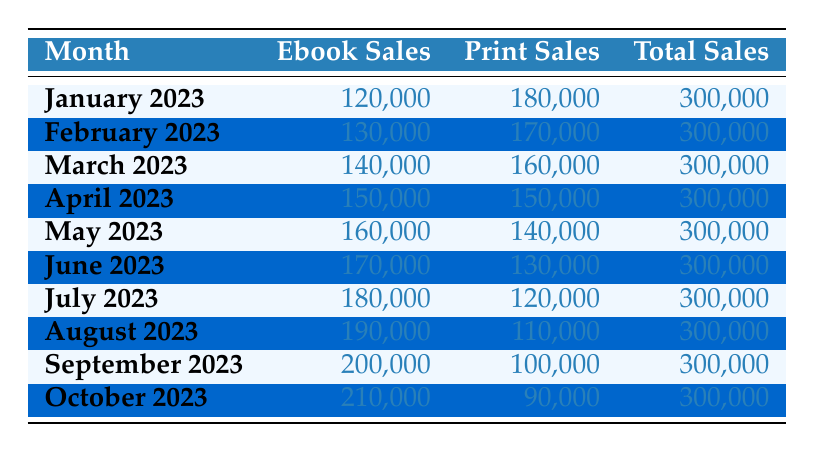What were the ebook sales in October 2023? Referring to the table, the ebook sales in October 2023 are listed directly in the corresponding row.
Answer: 210,000 What month saw the highest print sales? By examining the print sales column, we can see that January 2023 has the highest print sales at 180,000 among all months listed.
Answer: January 2023 What is the total number of ebook sales from January to March 2023? To find the total ebook sales, we add the values for January, February, and March: 120,000 + 130,000 + 140,000 = 390,000.
Answer: 390,000 Did ebook sales surpass print sales in the month of June 2023? In June 2023, the ebook sales are 170,000 and the print sales are 130,000. Therefore, ebook sales did surpass print sales.
Answer: Yes What is the difference between the total ebook sales in October and January 2023? The ebook sales in October 2023 are 210,000, and in January they are 120,000. The difference is 210,000 - 120,000 = 90,000.
Answer: 90,000 In which month did the total sales remain constant at 300,000 despite changes in ebook and print sales? The total sales for every month listed in the table remain constant at 300,000, confirming that this value is uniform across all months.
Answer: Every month What were the print sales in August 2023 compared to July 2023? In August 2023, print sales are 110,000, while in July 2023, they are 120,000. This shows a decrease in print sales by 10,000 from July to August.
Answer: Decreased by 10,000 What is the average ebook sales from January to October 2023? We first sum the ebook sales for all months (120,000 + 130,000 + 140,000 + 150,000 + 160,000 + 170,000 + 180,000 + 190,000 + 200,000 + 210,000 = 1,650,000). Then, to find the average, we divide by the number of months (10), yielding 1,650,000 / 10 = 165,000.
Answer: 165,000 How many months did print sales decline from the previous month? By reviewing the print sales column, we notice declines in print sales from January to February, from February to March, from March to April, from April to May, from May to June, from June to July, from July to August, from August to September, and from September to October. This indicates a consistent decline throughout the year.
Answer: Eight months 